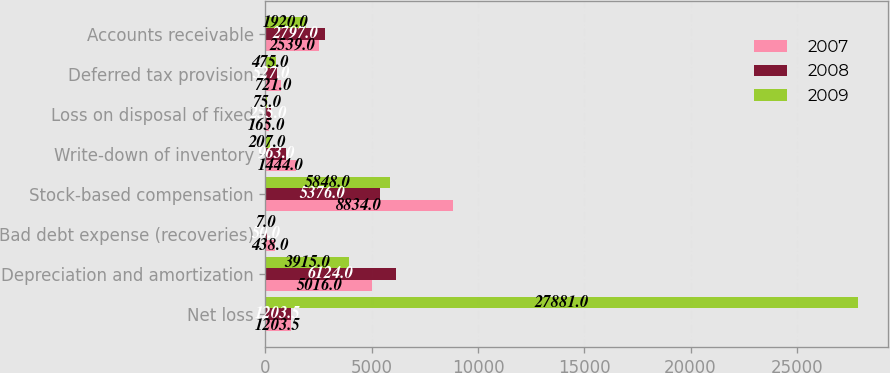<chart> <loc_0><loc_0><loc_500><loc_500><stacked_bar_chart><ecel><fcel>Net loss<fcel>Depreciation and amortization<fcel>Bad debt expense (recoveries)<fcel>Stock-based compensation<fcel>Write-down of inventory<fcel>Loss on disposal of fixed<fcel>Deferred tax provision<fcel>Accounts receivable<nl><fcel>2007<fcel>1203.5<fcel>5016<fcel>438<fcel>8834<fcel>1444<fcel>165<fcel>721<fcel>2539<nl><fcel>2008<fcel>1203.5<fcel>6124<fcel>50<fcel>5376<fcel>963<fcel>255<fcel>527<fcel>2797<nl><fcel>2009<fcel>27881<fcel>3915<fcel>7<fcel>5848<fcel>207<fcel>75<fcel>475<fcel>1920<nl></chart> 